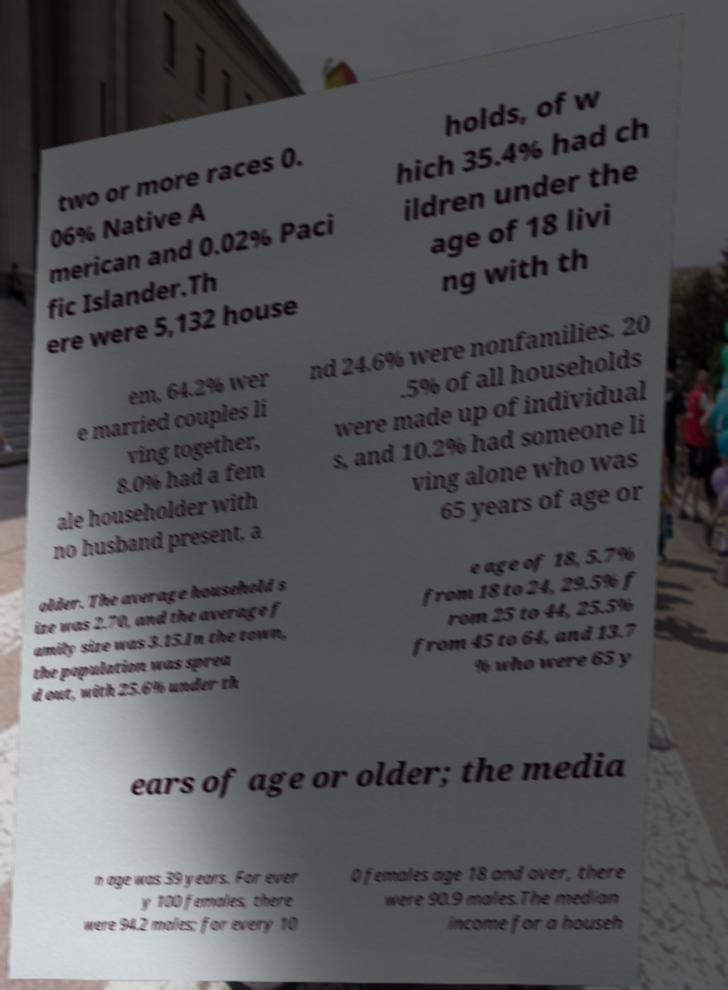Could you assist in decoding the text presented in this image and type it out clearly? two or more races 0. 06% Native A merican and 0.02% Paci fic Islander.Th ere were 5,132 house holds, of w hich 35.4% had ch ildren under the age of 18 livi ng with th em, 64.2% wer e married couples li ving together, 8.0% had a fem ale householder with no husband present, a nd 24.6% were nonfamilies. 20 .5% of all households were made up of individual s, and 10.2% had someone li ving alone who was 65 years of age or older. The average household s ize was 2.70, and the average f amily size was 3.15.In the town, the population was sprea d out, with 25.6% under th e age of 18, 5.7% from 18 to 24, 29.5% f rom 25 to 44, 25.5% from 45 to 64, and 13.7 % who were 65 y ears of age or older; the media n age was 39 years. For ever y 100 females, there were 94.2 males; for every 10 0 females age 18 and over, there were 90.9 males.The median income for a househ 